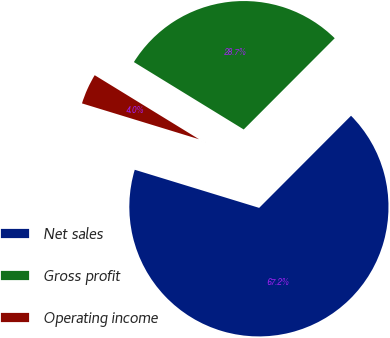Convert chart. <chart><loc_0><loc_0><loc_500><loc_500><pie_chart><fcel>Net sales<fcel>Gross profit<fcel>Operating income<nl><fcel>67.25%<fcel>28.72%<fcel>4.03%<nl></chart> 